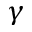Convert formula to latex. <formula><loc_0><loc_0><loc_500><loc_500>\gamma</formula> 